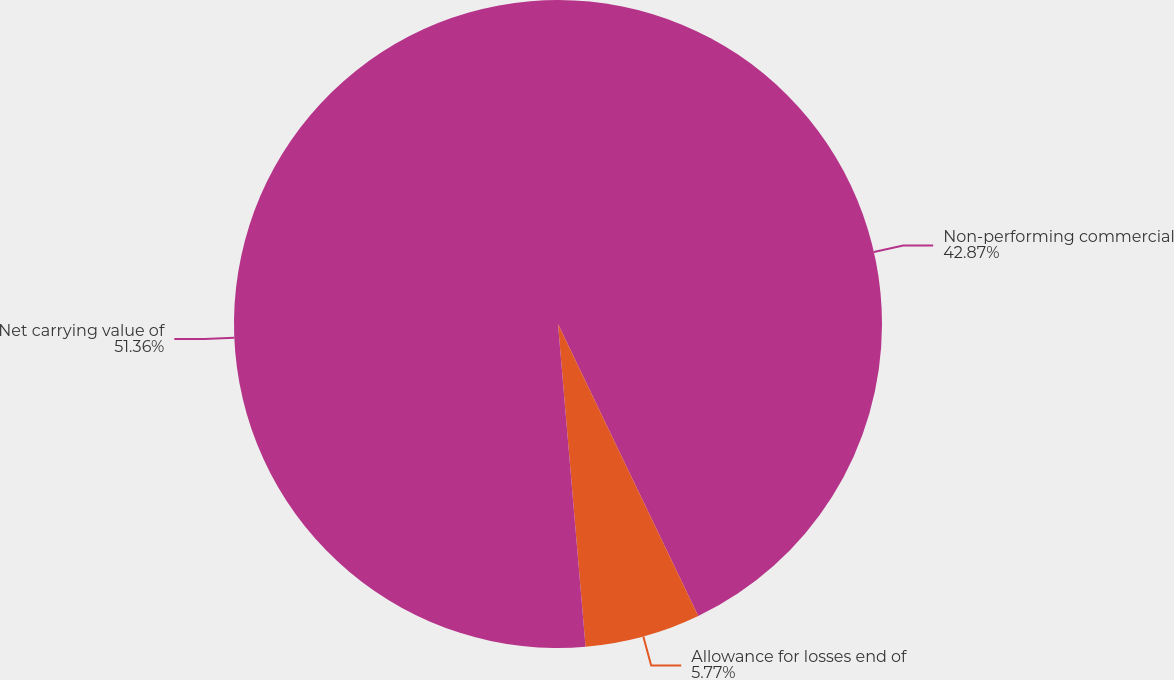Convert chart. <chart><loc_0><loc_0><loc_500><loc_500><pie_chart><fcel>Non-performing commercial<fcel>Allowance for losses end of<fcel>Net carrying value of<nl><fcel>42.87%<fcel>5.77%<fcel>51.35%<nl></chart> 